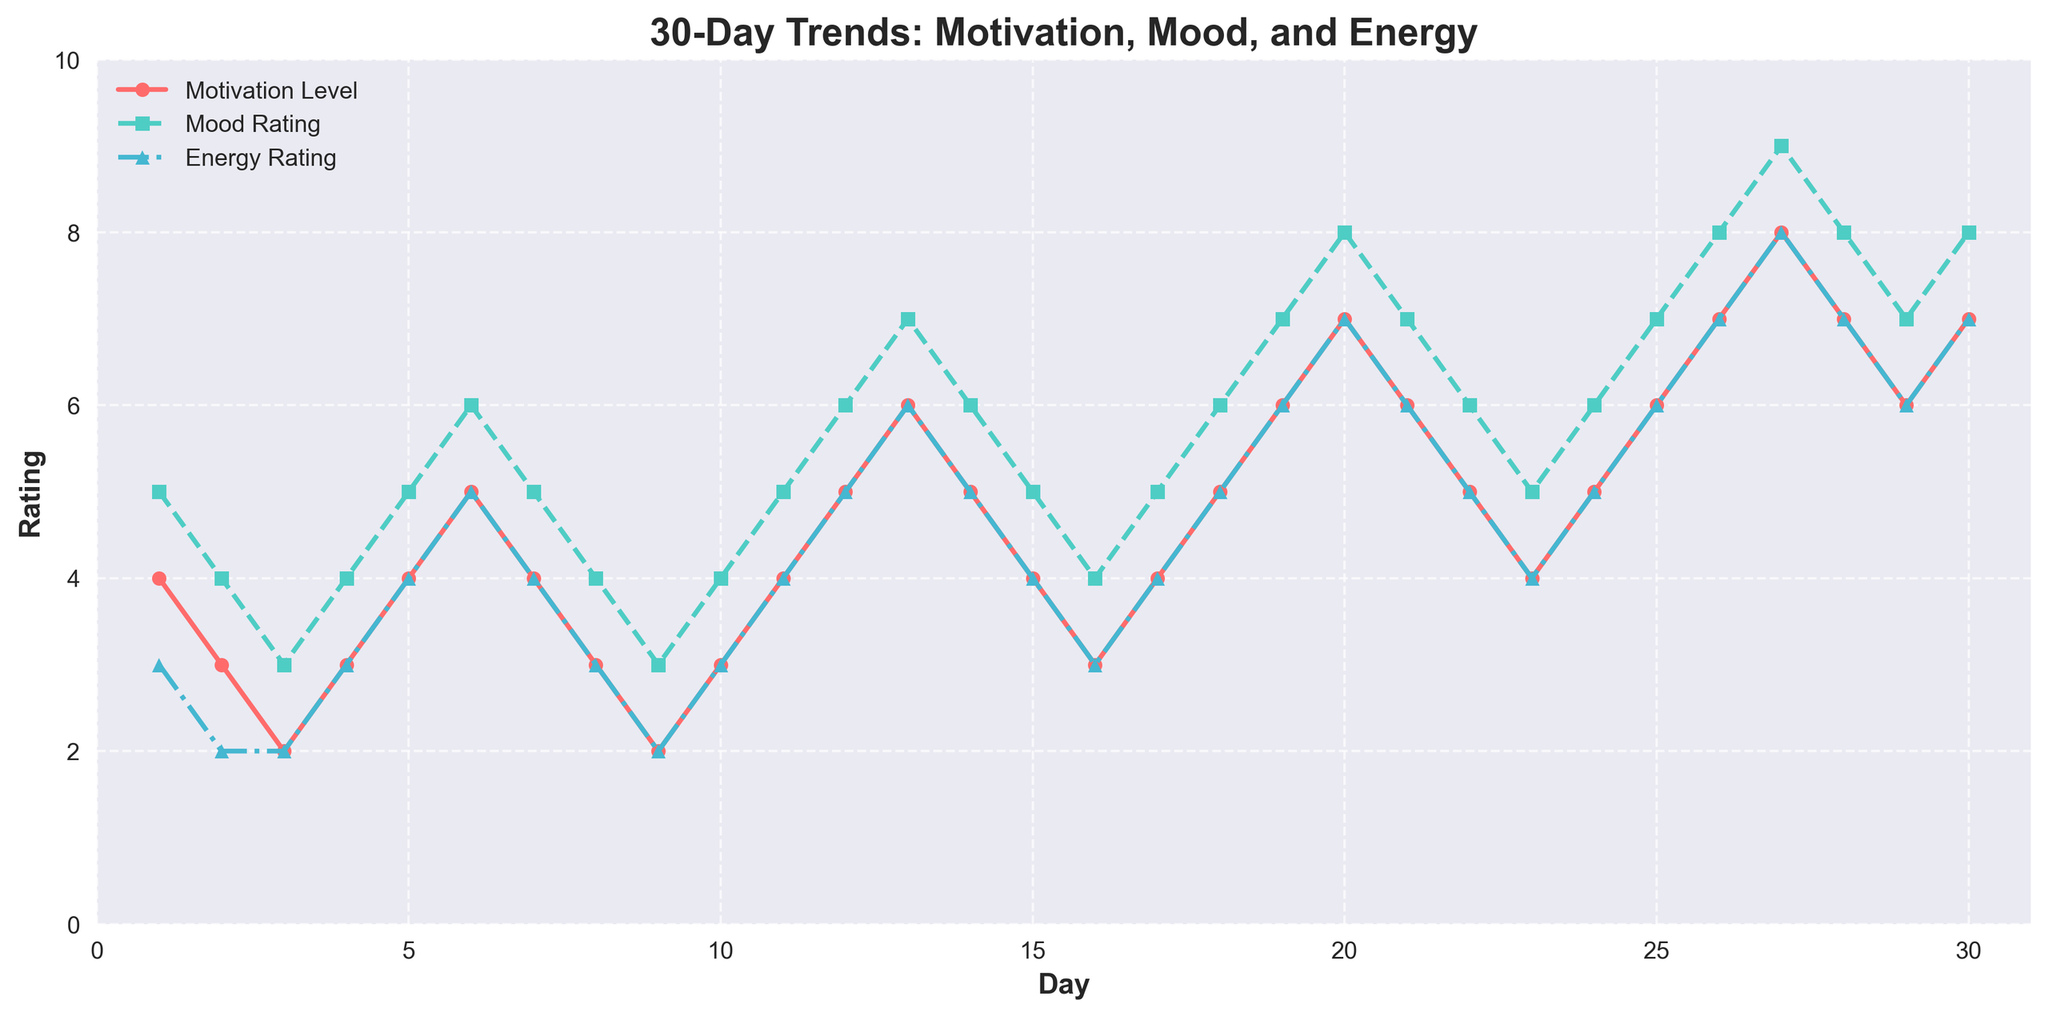What's the trend in Motivation Level from Day 1 to Day 30? The Motivation Level starts at 4 on Day 1 and generally increases over the 30 days, reaching 7 on Day 30 with occasional declines.
Answer: Increasing trend Which day shows the highest Energy Rating? By examining the figure, the Energy Rating peaks at 8 on Day 27.
Answer: Day 27 Compare Mood Rating and Energy Rating on Day 20. Which is higher? On Day 20, the Mood Rating and Energy Rating are both 8, making them equal.
Answer: Equal What is the average Motivation Level during the first 10 days? Adding the Motivation Levels from Day 1 to Day 10 (4+3+2+3+4+5+4+3+2+3) gives 33. Dividing by 10 gives an average of 3.3.
Answer: 3.3 On which days are the Mood Rating and Energy Rating both exactly the same? Mood Rating and Energy Rating are both the same on Days 6, 12, 18, 25, 26, 27, 28, 29, and 30.
Answer: Days 6, 12, 18, 25, 26, 27, 28, 29, and 30 Does the Motivational Level ever exceed the Mood Rating? Throughout the 30 days, the Motivation Level never exceeds the Mood Rating.
Answer: No By looking at the general trend, how is the Mood Rating correlated with the Energy Rating? Both Mood Rating and Energy Rating exhibit similar trends, rising and falling together, indicating a positive correlation.
Answer: Positively correlated Calculate the difference in Motivation Level between its highest and lowest points. The highest Motivation Level is 8 (Day 27), and the lowest is 2 (Days 3 & 9). The difference is 8 - 2 = 6.
Answer: 6 Identify a period where all three ratings (Motivation, Mood, and Energy) increase consistently over several days. From Day 24 to Day 27, Motivation Level rises from 5 to 8, Mood Rating from 6 to 9, and Energy Rating from 5 to 8.
Answer: Days 24-27 Which rating shows the most volatile pattern over the 30 days? The Energy Rating changes the most noticeably, exhibiting sharp rises and falls compared to Motivation Level and Mood Rating.
Answer: Energy Rating 